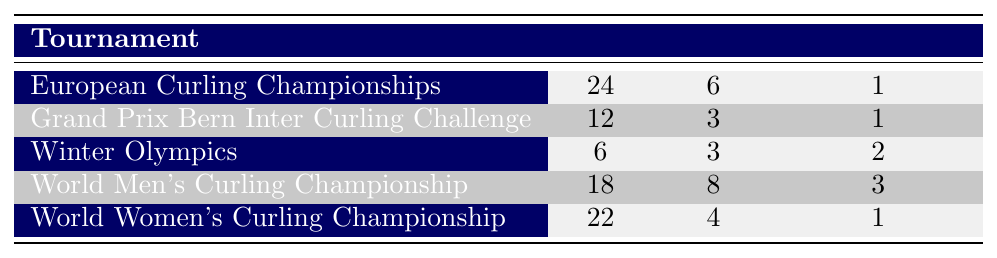What is the total number of wins for the Swiss Men's team in the European Curling Championships? The table shows that the Swiss Men's team has a total of 24 wins in the European Curling Championships, which is explicitly stated in the table.
Answer: 24 What is the best placing achieved by the Switzerland Women team in the World Women's Curling Championship? According to the table, the best placing achieved by the Switzerland Women team in the World Women's Curling Championship is 1, as indicated in the table under this specific tournament entry.
Answer: 1 How many total losses did Switzerland Women incur across all tournaments listed? The total losses for Switzerland Women can be calculated by adding the losses from different rows in the table: 3 (2016) + 1 (2017) + 1 (2021) = 5. Thus, they incurred a total of 5 losses across all tournaments mentioned.
Answer: 5 Did the Switzerland Men team ever achieve a placing of 1 in any tournament? The table indicates that the highest placing for the Switzerland Men team is 3 in the World Men's Curling Championship, and they never placed 1 in any tournament listed.
Answer: No What is the average number of losses for the Switzerland Men team in the tournaments listed? The Switzerland Men team has three entries with losses of 3 (2013), 4 (2014), and 4 (2019). To find the average, sum the losses (3 + 4 + 4 = 11) and divide by the number of tournaments (3), resulting in an average of 11/3 = 3.67.
Answer: 3.67 Which tournament did the Switzerland Women team have the most wins? By checking the table, the Switzerland Women team had the most wins in the 2021 World Women's Curling Championship with 12 wins, compared to the 10 in 2016 and 10 in 2017.
Answer: World Women's Curling Championship (2021) What is the total number of wins for the Swiss teams in the Grand Prix Bern Inter Curling Challenge? The table shows two entries for this tournament: 7 wins by Bern Zähringer in 2015 and 5 wins by Genève in 2020. The total number of wins is 7 + 5 = 12.
Answer: 12 Did the Switzerland Mixed Doubles team achieve a placing better than 3 in the Winter Olympics? The table states that the Switzerland Mixed Doubles team placed 2 in the Winter Olympics, which is better than 3.
Answer: Yes What is the difference in total wins between the Switzerland Women and the Switzerland Men teams across all tournaments? By summing the wins, Switzerland Women has (10 + 10 + 12) = 32 total wins, while Switzerland Men has (6 + 9 + 9 + 8) = 32 total wins. The difference is 32 - 32 = 0.
Answer: 0 